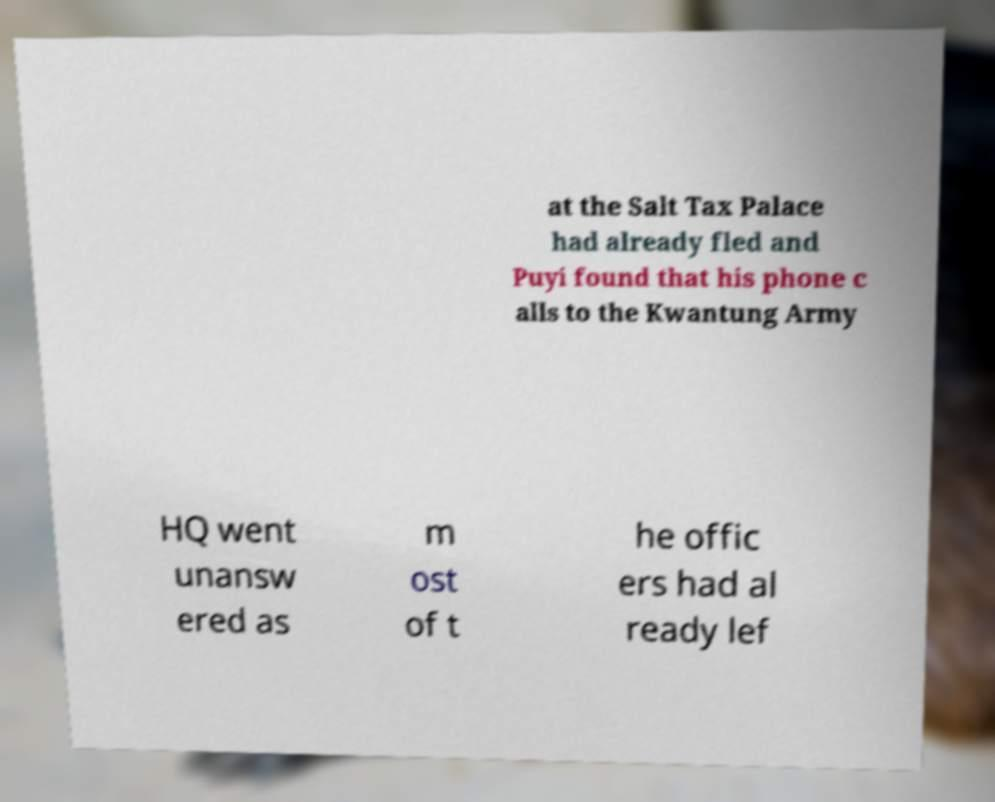I need the written content from this picture converted into text. Can you do that? at the Salt Tax Palace had already fled and Puyi found that his phone c alls to the Kwantung Army HQ went unansw ered as m ost of t he offic ers had al ready lef 